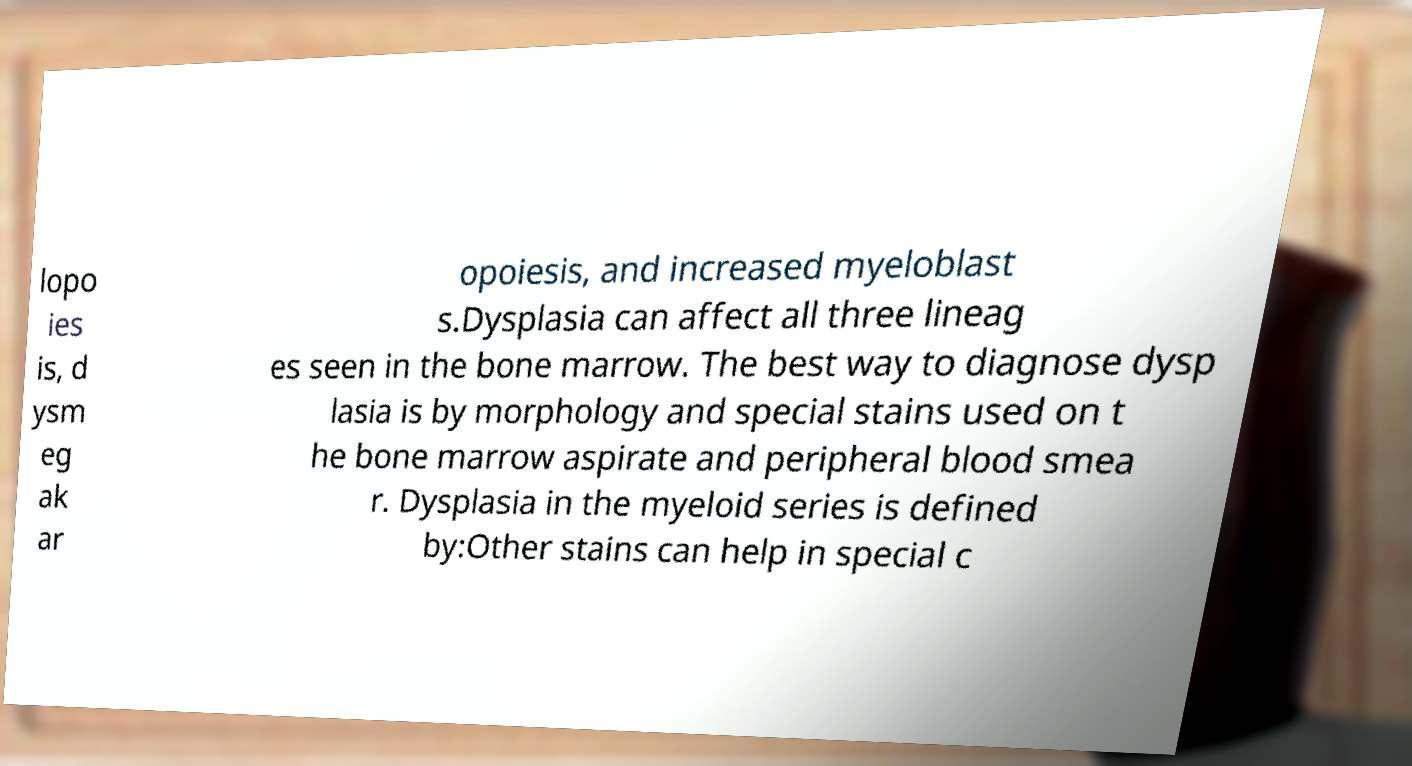Please identify and transcribe the text found in this image. lopo ies is, d ysm eg ak ar opoiesis, and increased myeloblast s.Dysplasia can affect all three lineag es seen in the bone marrow. The best way to diagnose dysp lasia is by morphology and special stains used on t he bone marrow aspirate and peripheral blood smea r. Dysplasia in the myeloid series is defined by:Other stains can help in special c 